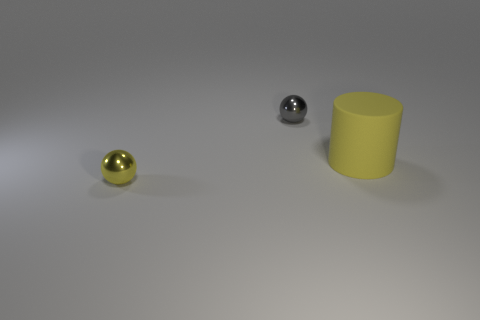Subtract all gray balls. How many balls are left? 1 Add 2 big yellow matte cylinders. How many objects exist? 5 Subtract all cylinders. How many objects are left? 2 Subtract 1 cylinders. How many cylinders are left? 0 Add 3 yellow things. How many yellow things exist? 5 Subtract 0 gray blocks. How many objects are left? 3 Subtract all blue spheres. Subtract all cyan cubes. How many spheres are left? 2 Subtract all large red cylinders. Subtract all yellow objects. How many objects are left? 1 Add 2 yellow metal things. How many yellow metal things are left? 3 